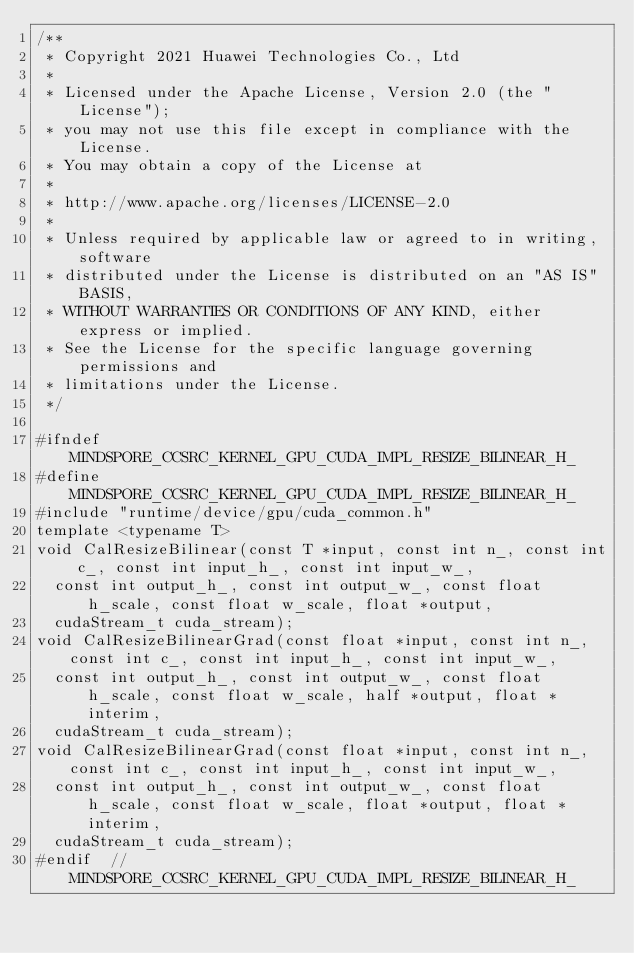Convert code to text. <code><loc_0><loc_0><loc_500><loc_500><_Cuda_>/**
 * Copyright 2021 Huawei Technologies Co., Ltd
 *
 * Licensed under the Apache License, Version 2.0 (the "License");
 * you may not use this file except in compliance with the License.
 * You may obtain a copy of the License at
 *
 * http://www.apache.org/licenses/LICENSE-2.0
 *
 * Unless required by applicable law or agreed to in writing, software
 * distributed under the License is distributed on an "AS IS" BASIS,
 * WITHOUT WARRANTIES OR CONDITIONS OF ANY KIND, either express or implied.
 * See the License for the specific language governing permissions and
 * limitations under the License.
 */

#ifndef MINDSPORE_CCSRC_KERNEL_GPU_CUDA_IMPL_RESIZE_BILINEAR_H_
#define MINDSPORE_CCSRC_KERNEL_GPU_CUDA_IMPL_RESIZE_BILINEAR_H_
#include "runtime/device/gpu/cuda_common.h"
template <typename T>
void CalResizeBilinear(const T *input, const int n_, const int c_, const int input_h_, const int input_w_,
  const int output_h_, const int output_w_, const float h_scale, const float w_scale, float *output,
  cudaStream_t cuda_stream);
void CalResizeBilinearGrad(const float *input, const int n_, const int c_, const int input_h_, const int input_w_,
  const int output_h_, const int output_w_, const float h_scale, const float w_scale, half *output, float *interim,
  cudaStream_t cuda_stream);
void CalResizeBilinearGrad(const float *input, const int n_, const int c_, const int input_h_, const int input_w_,
  const int output_h_, const int output_w_, const float h_scale, const float w_scale, float *output, float *interim,
  cudaStream_t cuda_stream);
#endif  // MINDSPORE_CCSRC_KERNEL_GPU_CUDA_IMPL_RESIZE_BILINEAR_H_
</code> 